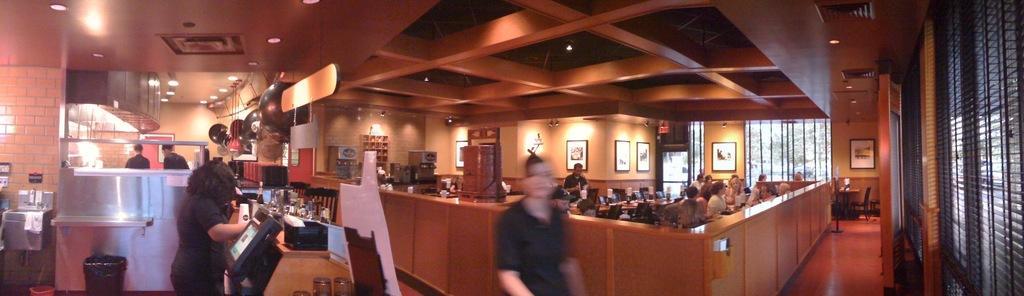Can you describe this image briefly? This picture is clicked inside the hall. On the right corner we can see the metal rods and a door. In the center we can see the group of persons sitting and we can see the electronic devices, picture frames hanging on the wall, roof, ceiling lights, group of persons, bottles, chairs and some objects hanging on the roof. On the left we can see a wash basin and many other objects. In the background we can see the cabinet containing some objects, we can see the tables and many other objects. 